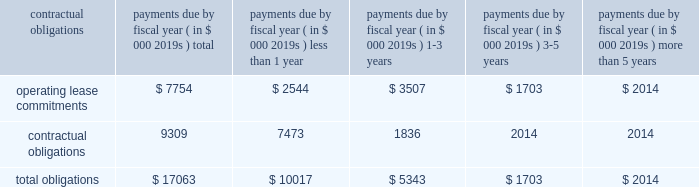97% ( 97 % ) of its carrying value .
The columbia fund is being liquidated with distributions to us occurring and expected to be fully liquidated during calendar 2008 .
Since december 2007 , we have received disbursements of approximately $ 20.7 million from the columbia fund .
Our operating activities during the year ended march 31 , 2008 used cash of $ 28.9 million as compared to $ 19.8 million during the same period in the prior year .
Our fiscal 2008 net loss of $ 40.9 million was the primary cause of our cash use from operations , attributed to increased investments in our global distribution as we continue to drive initiatives to increase recovery awareness as well as our investments in research and development to broaden our circulatory care product portfolio .
In addition , our inventories used cash of $ 11.1 million during fiscal 2008 , reflecting our inventory build-up to support anticipated increases in global demand for our products and our accounts receivable also increased as a result of higher sales volume resulting in a use of cash of $ 2.8 million in fiscal 2008 .
These decreases in cash were partially offset by an increase in accounts payable and accrued expenses of $ 5.6 million , non-cash adjustments of $ 5.4 million related to stock-based compensation expense , $ 6.1 million of depreciation and amortization and $ 5.0 million for the change in fair value of worldheart note receivable and warrant .
Our investing activities during the year ended march 31 , 2008 used cash of $ 40.9 million as compared to cash provided by investing activities of $ 15.1 million during the year ended march 31 , 2007 .
Cash used by investment activities for fiscal 2008 consisted primarily of $ 49.3 million for the recharacterization of the columbia fund to short-term marketable securities , $ 17.1 million for the purchase of short-term marketable securities , $ 3.8 million related to expenditures for property and equipment and $ 5.0 million for note receivable advanced to worldheart .
These amounts were offset by $ 34.5 million of proceeds from short-term marketable securities .
In june 2008 , we received 510 ( k ) clearance of our impella 2.5 , triggering an obligation to pay $ 5.6 million of contingent payments in accordance with the may 2005 acquisition of impella .
These contingent payments may be made , at our option , with cash , or stock or by a combination of cash or stock under circumstances described in the purchase agreement .
It is our intent to satisfy this contingent payment through the issuance of shares of our common stock .
Our financing activities during the year ended march 31 , 2008 provided cash of $ 2.1 million as compared to cash provided by financing activities of $ 66.6 million during the same period in the prior year .
Cash provided by financing activities for fiscal 2008 is comprised primarily of $ 2.8 million attributable to the exercise of stock options , $ 0.9 million related to the proceeds from the issuance of common stock , $ 0.3 million related to proceeds from the employee stock purchase plan , partially offset by $ 1.9 million related to the repurchase of warrants .
The $ 64.5 million decrease compared to the prior year is primarily due to $ 63.6 million raised from the public offering in fiscal 2007 .
We disbursed approximately $ 2.2 million of cash for the warrant repurchase and settlement of certain litigation .
Capital expenditures for fiscal 2009 are estimated to be approximately $ 3.0 to $ 6.0 million .
Contractual obligations and commercial commitments the table summarizes our contractual obligations at march 31 , 2008 and the effects such obligations are expected to have on our liquidity and cash flows in future periods .
Payments due by fiscal year ( in $ 000 2019s ) contractual obligations total than 1 than 5 .
We have no long-term debt , capital leases or other material commitments , for open purchase orders and clinical trial agreements at march 31 , 2008 other than those shown in the table above .
In may 2005 , we acquired all the shares of outstanding capital stock of impella cardiosystems ag , a company headquartered in aachen , germany .
The aggregate purchase price excluding a contingent payment in the amount of $ 5.6 million made on january 30 , 2007 in the form of common stock , was approximately $ 45.1 million , which consisted of $ 42.2 million of our common stock , $ 1.6 million of cash paid to certain former shareholders of impella and $ 1.3 million of transaction costs , consisting primarily of fees paid for financial advisory and legal services .
We may make additional contingent payments to impella 2019s former shareholders based on additional milestone payments related to fda approvals in the amount of up to $ 11.2 million .
In june 2008 we received 510 ( k ) clearance of our impella 2.5 , triggering an obligation to pay $ 5.6 million of contingent payments .
These contingent payments may be made , at our option , with cash , or stock or by a combination of cash or stock under circumstances described in the purchase agreement , except that approximately $ 1.8 million of these contingent payments must be made in cash .
The payment of any contingent payments will result in an increase to the carrying value of goodwill .
We apply the disclosure provisions of fin no .
45 , guarantor 2019s accounting and disclosure requirements for guarantees , including guarantees of indebtedness of others , and interpretation of fasb statements no .
5 , 57 and 107 and rescission of fasb interpretation .
Assuming the same level of cash from financing activities in 2009 as during the year ended march 31 , 2008 , would this be sufficient to cover the project capital expenditures for fiscal 2009? 
Computations: (2.1 > 3.0)
Answer: no. 